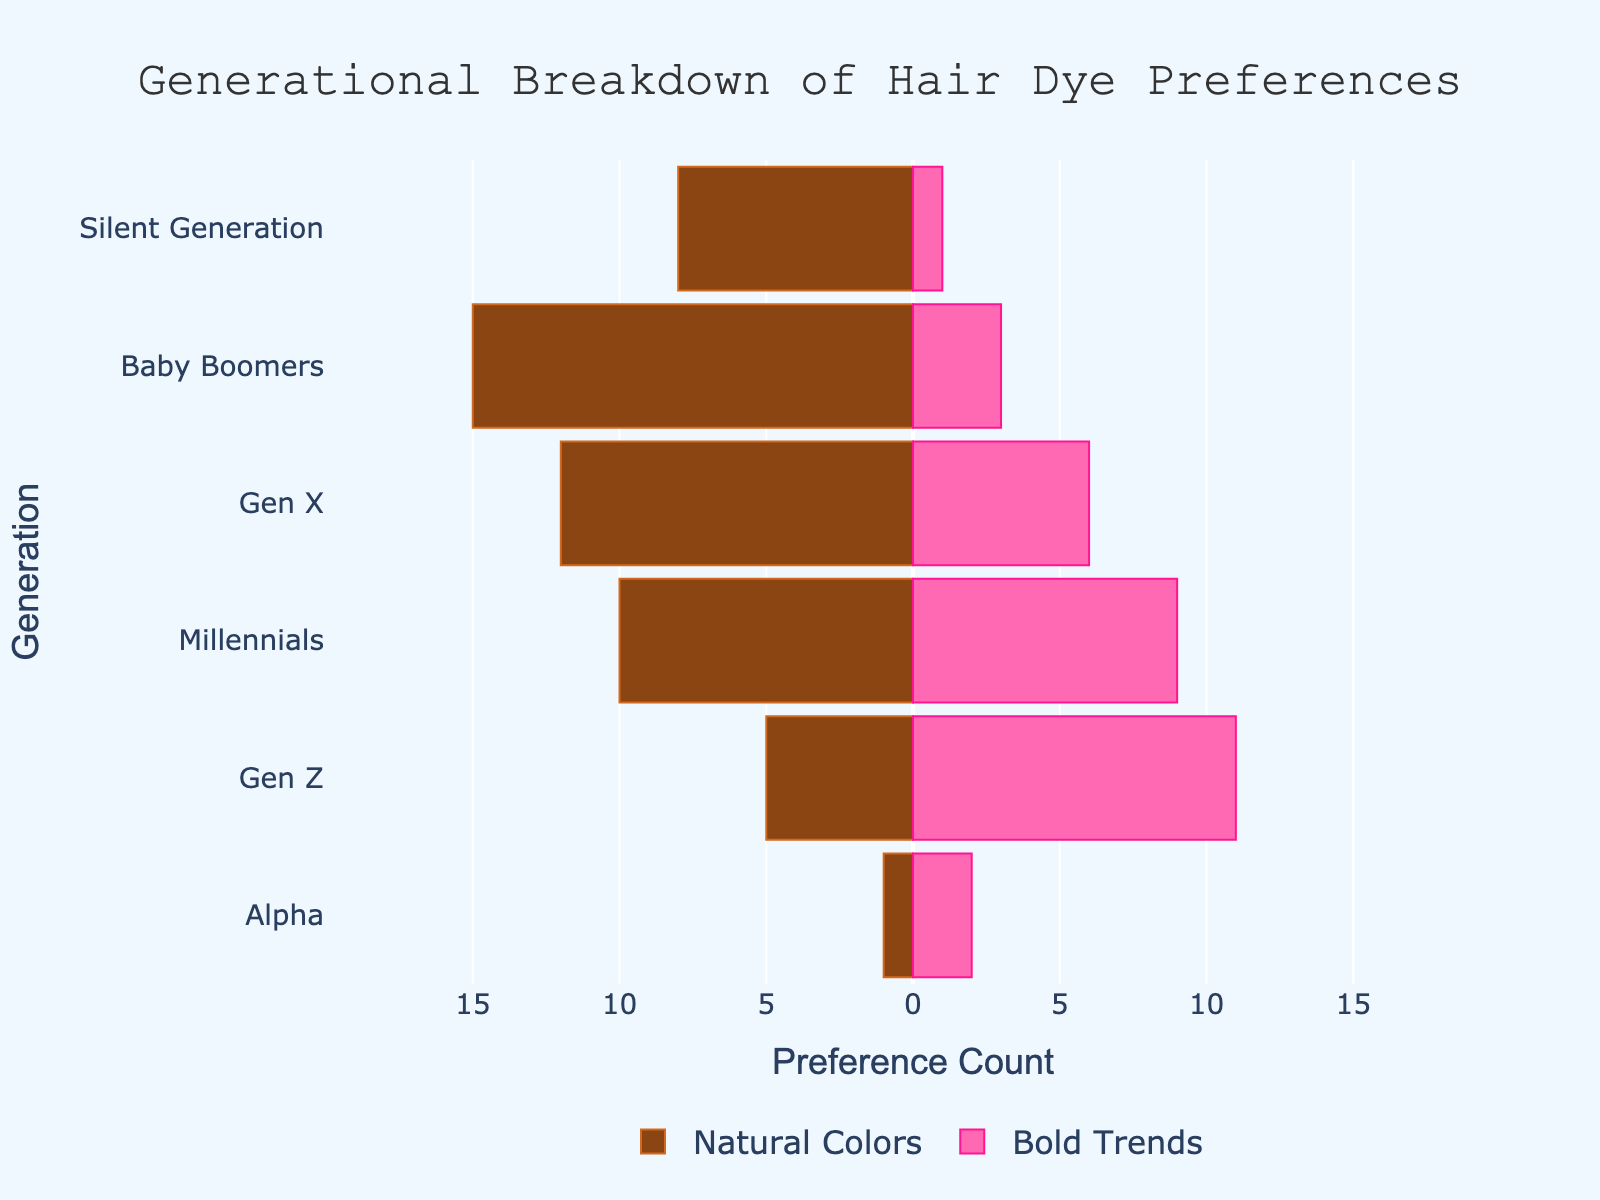Which generation shows the highest preference for natural colors? To find this, look at the bar with the highest value on the left side (Natural Colors). Baby Boomers have the longest bar for natural colors.
Answer: Baby Boomers In which generation is the preference for bold trends higher than natural colors? Identify the generations where the bar on the right side (Bold Trends) is longer than the corresponding bar on the left side (Natural Colors). This happens for Millennials, Gen Z, and Alpha.
Answer: Millennials, Gen Z, Alpha What is the total number of people who prefer natural colors in Baby Boomers and Gen X combined? Add the corresponding values from the two generations: Baby Boomers (15) and Gen X (12). 15 + 12 = 27
Answer: 27 Which generation has the smallest preference for natural colors? Find the shortest bar on the left side, which represents the number of people who prefer natural colors. The Alpha generation shows the smallest preference with a value of 1.
Answer: Alpha How does the preference for bold trends in Gen Z compare to Millennials? Compare the lengths of the right-side bars for Gen Z and Millennials. Gen Z has a value of 11, while Millennials have 9. 11 is greater than 9, so Gen Z has a higher preference for bold trends.
Answer: Gen Z By how much does the preference for bold trends in Gen X exceed that of the Silent Generation? Subtract the value for the Silent Generation (1) from the value for Gen X (6). 6 - 1 = 5
Answer: 5 How does the preference for natural colors change from the Baby Boomers to Gen X? Compare the bar lengths on the left side for both generations. Baby Boomers have 15, and Gen X has 12. The preference decreases by 3.
Answer: Decreases by 3 Which generation shows a preference for bold trends that is roughly equal to their preference for natural colors? Identify where both bars (left and right) are nearly the same length. This occurs for Millennials where bold trends (9) are close to natural colors (10).
Answer: Millennials What is the total preference for bold trends across all generations? Sum the values for bold trends across all generations: 1 (Silent Generation) + 3 (Baby Boomers) + 6 (Gen X) + 9 (Millennials) + 11 (Gen Z) + 2 (Alpha) = 32
Answer: 32 Which generation's preference for natural colors is closest to that of Millennials? Compare the value for Millennials (10) with other generations and find the closest match. Gen X has a value of 12, which is closest to 10.
Answer: Gen X 